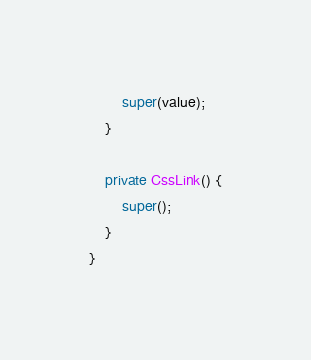<code> <loc_0><loc_0><loc_500><loc_500><_Java_>		super(value);
	}

	private CssLink() {
		super();
	}
}
</code> 